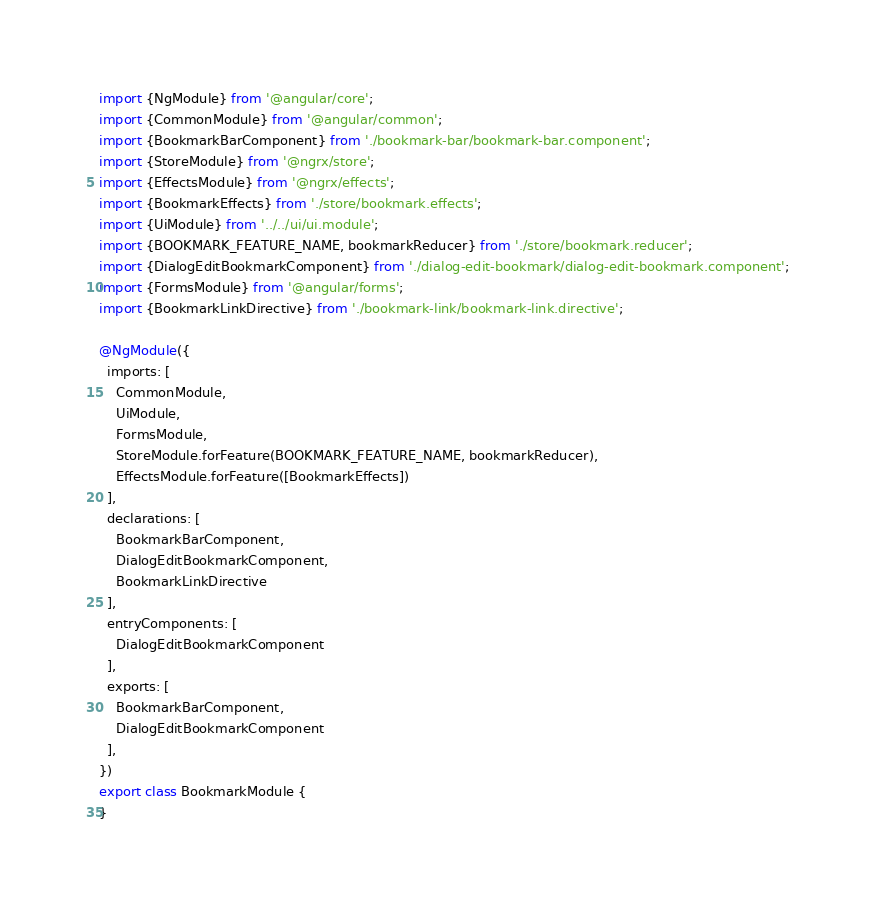Convert code to text. <code><loc_0><loc_0><loc_500><loc_500><_TypeScript_>import {NgModule} from '@angular/core';
import {CommonModule} from '@angular/common';
import {BookmarkBarComponent} from './bookmark-bar/bookmark-bar.component';
import {StoreModule} from '@ngrx/store';
import {EffectsModule} from '@ngrx/effects';
import {BookmarkEffects} from './store/bookmark.effects';
import {UiModule} from '../../ui/ui.module';
import {BOOKMARK_FEATURE_NAME, bookmarkReducer} from './store/bookmark.reducer';
import {DialogEditBookmarkComponent} from './dialog-edit-bookmark/dialog-edit-bookmark.component';
import {FormsModule} from '@angular/forms';
import {BookmarkLinkDirective} from './bookmark-link/bookmark-link.directive';

@NgModule({
  imports: [
    CommonModule,
    UiModule,
    FormsModule,
    StoreModule.forFeature(BOOKMARK_FEATURE_NAME, bookmarkReducer),
    EffectsModule.forFeature([BookmarkEffects])
  ],
  declarations: [
    BookmarkBarComponent,
    DialogEditBookmarkComponent,
    BookmarkLinkDirective
  ],
  entryComponents: [
    DialogEditBookmarkComponent
  ],
  exports: [
    BookmarkBarComponent,
    DialogEditBookmarkComponent
  ],
})
export class BookmarkModule {
}
</code> 